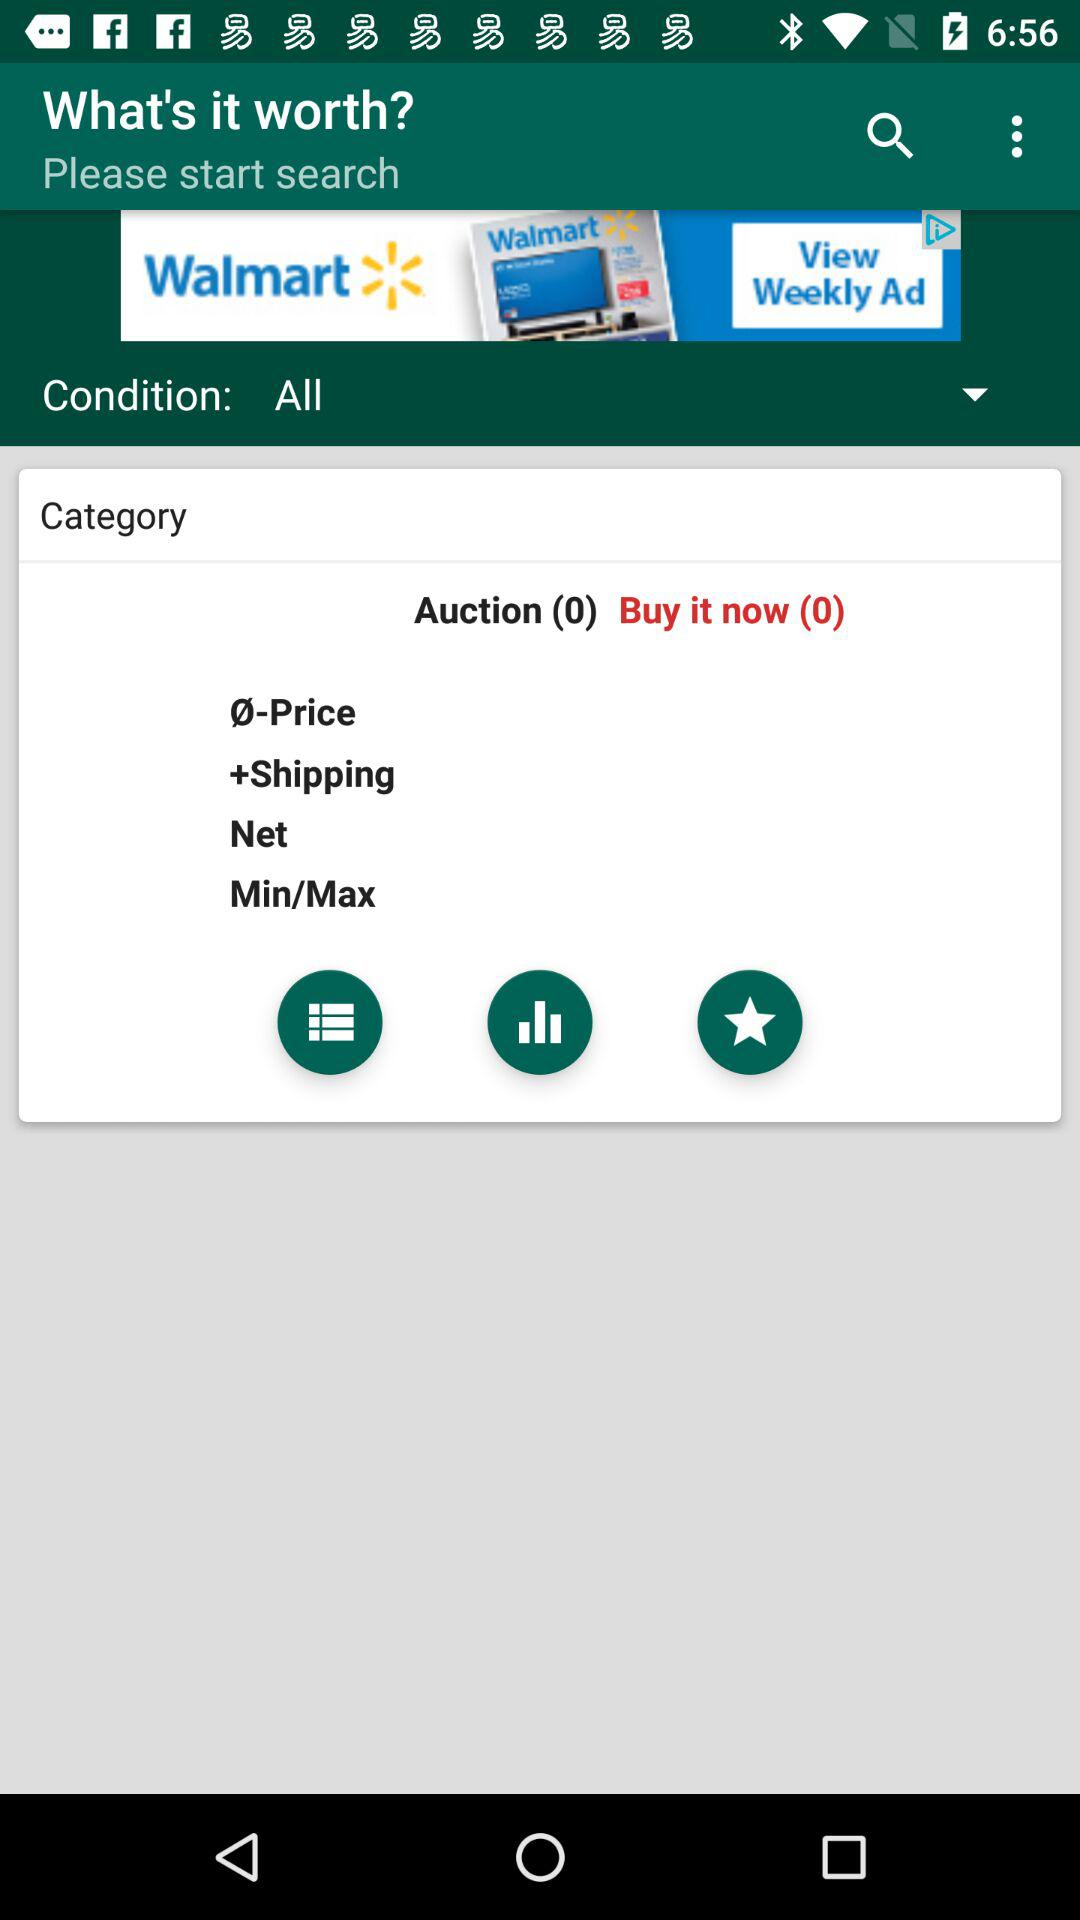What are the available categories? The available categories are "Ø-Price", "+Shipping", "Net" and "Min/Max". 